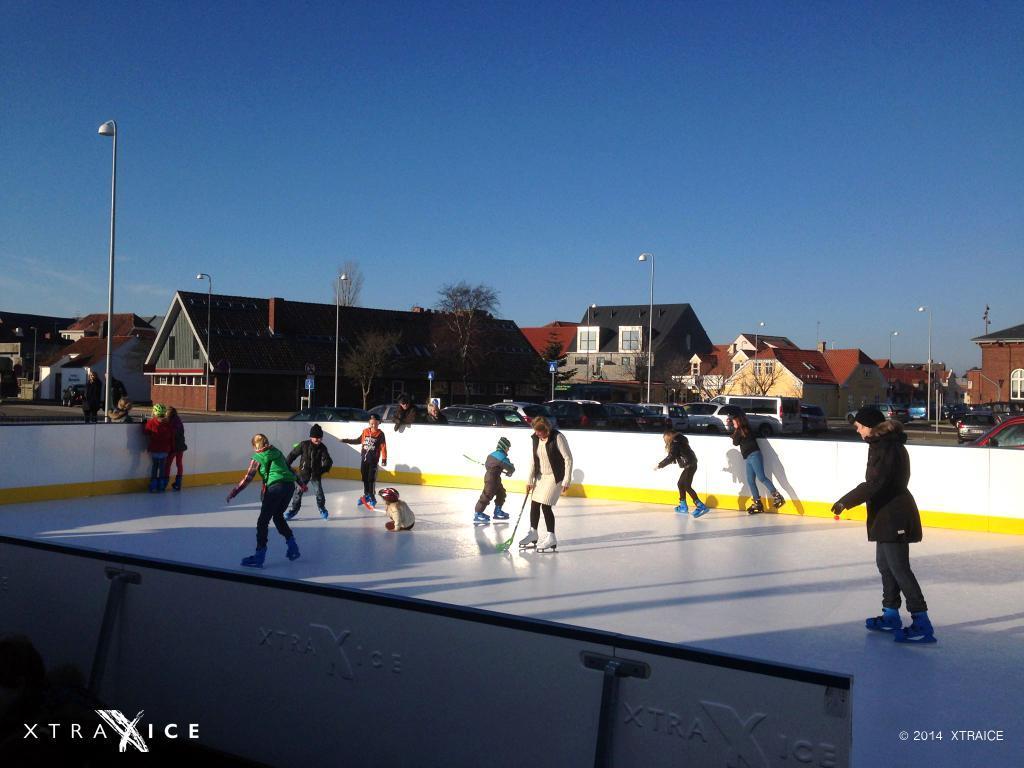Could you give a brief overview of what you see in this image? In the foreground I can see a group of people are skating and playing a hockey on the ground. In the background I can see fleets of cars and vehicles on the road, houses, buildings and poles. At the top I can see the blue sky. This image is taken during a day. 